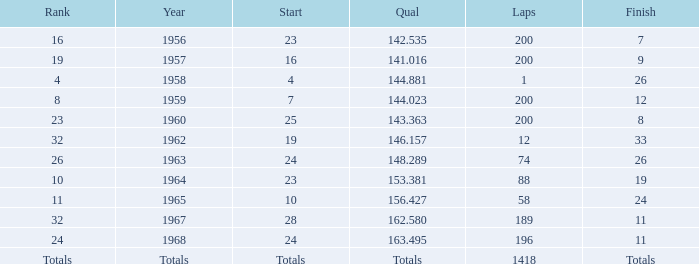Parse the table in full. {'header': ['Rank', 'Year', 'Start', 'Qual', 'Laps', 'Finish'], 'rows': [['16', '1956', '23', '142.535', '200', '7'], ['19', '1957', '16', '141.016', '200', '9'], ['4', '1958', '4', '144.881', '1', '26'], ['8', '1959', '7', '144.023', '200', '12'], ['23', '1960', '25', '143.363', '200', '8'], ['32', '1962', '19', '146.157', '12', '33'], ['26', '1963', '24', '148.289', '74', '26'], ['10', '1964', '23', '153.381', '88', '19'], ['11', '1965', '10', '156.427', '58', '24'], ['32', '1967', '28', '162.580', '189', '11'], ['24', '1968', '24', '163.495', '196', '11'], ['Totals', 'Totals', 'Totals', 'Totals', '1418', 'Totals']]} What is the highest number of laps that also has a finish total of 8? 200.0. 